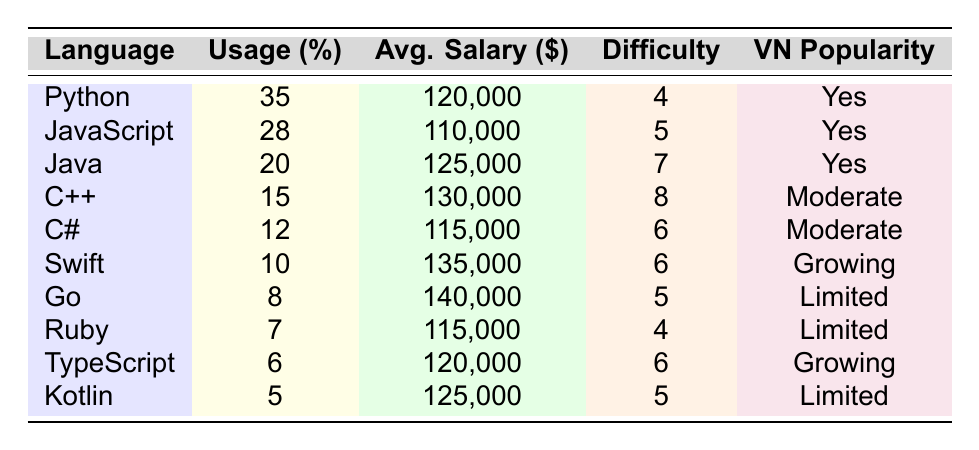What is the most popular programming language in US tech companies? The table indicates that Python has the highest usage percentage at 35%, making it the most popular programming language in US tech companies.
Answer: Python Which programming language has the highest average salary? Looking at the average salary column, Swift has the highest average salary listed at $135,000, which is more than any other programming language in the table.
Answer: Swift Is Java popular in the Vietnamese tech scene? The table states that Java is marked as "Yes" in the Popular in Vietnamese Tech Scene column, indicating that it is indeed popular among Vietnamese tech professionals.
Answer: Yes What is the average programming language salary for the top three languages? The top three languages are Python, JavaScript, and Java with salaries of $120,000, $110,000, and $125,000 respectively. Summing these gives $120,000 + $110,000 + $125,000 = $355,000. Dividing by 3 (the number of languages) gives an average of $355,000 / 3 = $118,333.33.
Answer: 118333.33 Which programming language has the same level of learning difficulty as C#? The learning difficulty for C# is listed as 6. By reviewing the "Learning Difficulty" column, both Swift and TypeScript also have a difficulty rating of 6, which means they share the same level of learning difficulty as C#.
Answer: Swift and TypeScript What is the total percentage usage of the least popular programming languages? The least popular languages in the table are Go (8%), Ruby (7%), TypeScript (6%), and Kotlin (5%). Adding these gives: 8 + 7 + 6 + 5 = 26%.
Answer: 26% Is there a programming language that is considered "Growing" in popularity in the Vietnamese tech scene? The table lists Swift and TypeScript as "Growing" under the Popular in Vietnamese Tech Scene column, indicating that there are indeed languages considered to be gaining popularity.
Answer: Yes What is the difference in average salary between the most and least popular programming languages? Python, the most popular language, has an average salary of $120,000, while Kotlin, the least popular, has an average salary of $125,000. The difference is calculated as $135,000 - $115,000 = $20,000.
Answer: 20,000 Which language has a higher learning difficulty: Java or C++? The learning difficulty for Java is 7 and for C++ is 8. Since 8 is greater than 7, C++ has a higher learning difficulty than Java.
Answer: C++ How many programming languages have a learning difficulty of 5 or lower? The languages with a learning difficulty of 5 or lower are Python (4), Ruby (4), Go (5), and JavaScript (5). Counting these gives a total of 4 languages.
Answer: 4 